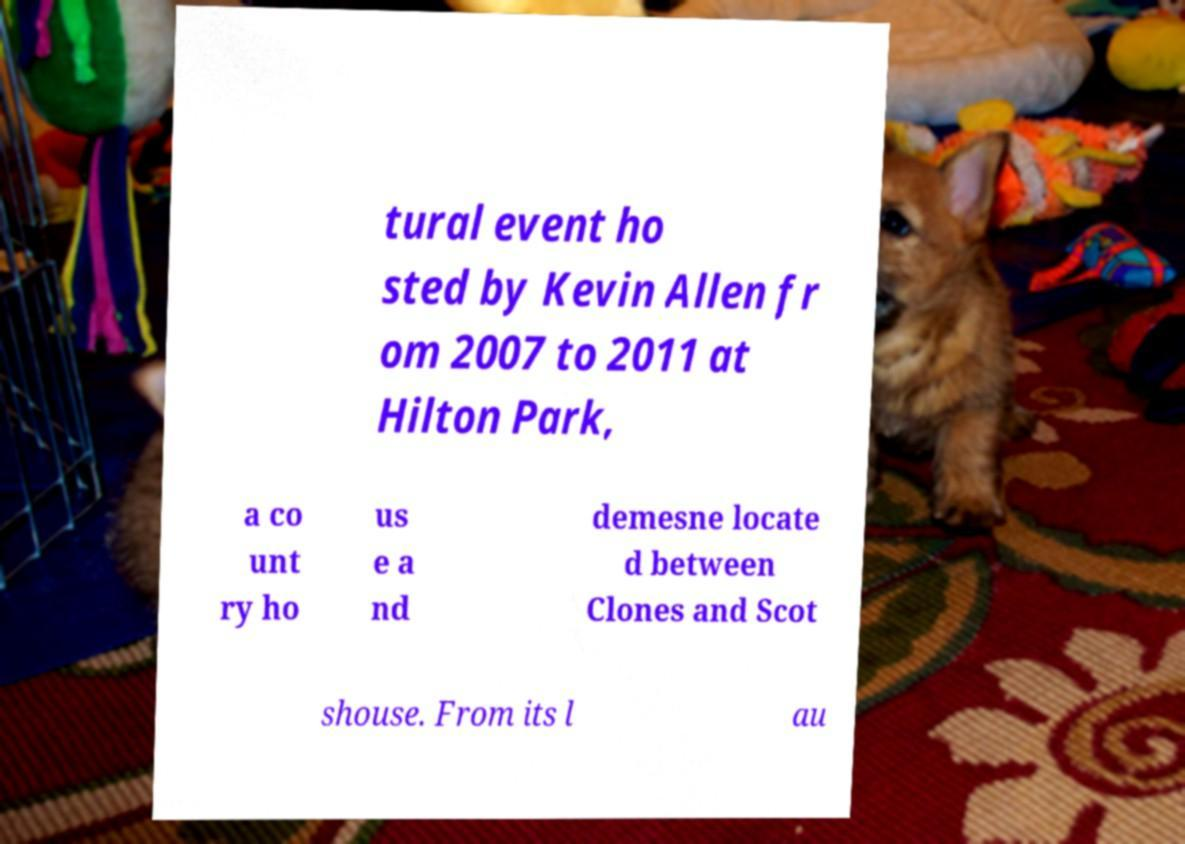For documentation purposes, I need the text within this image transcribed. Could you provide that? tural event ho sted by Kevin Allen fr om 2007 to 2011 at Hilton Park, a co unt ry ho us e a nd demesne locate d between Clones and Scot shouse. From its l au 